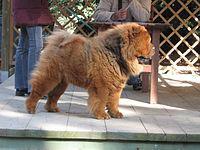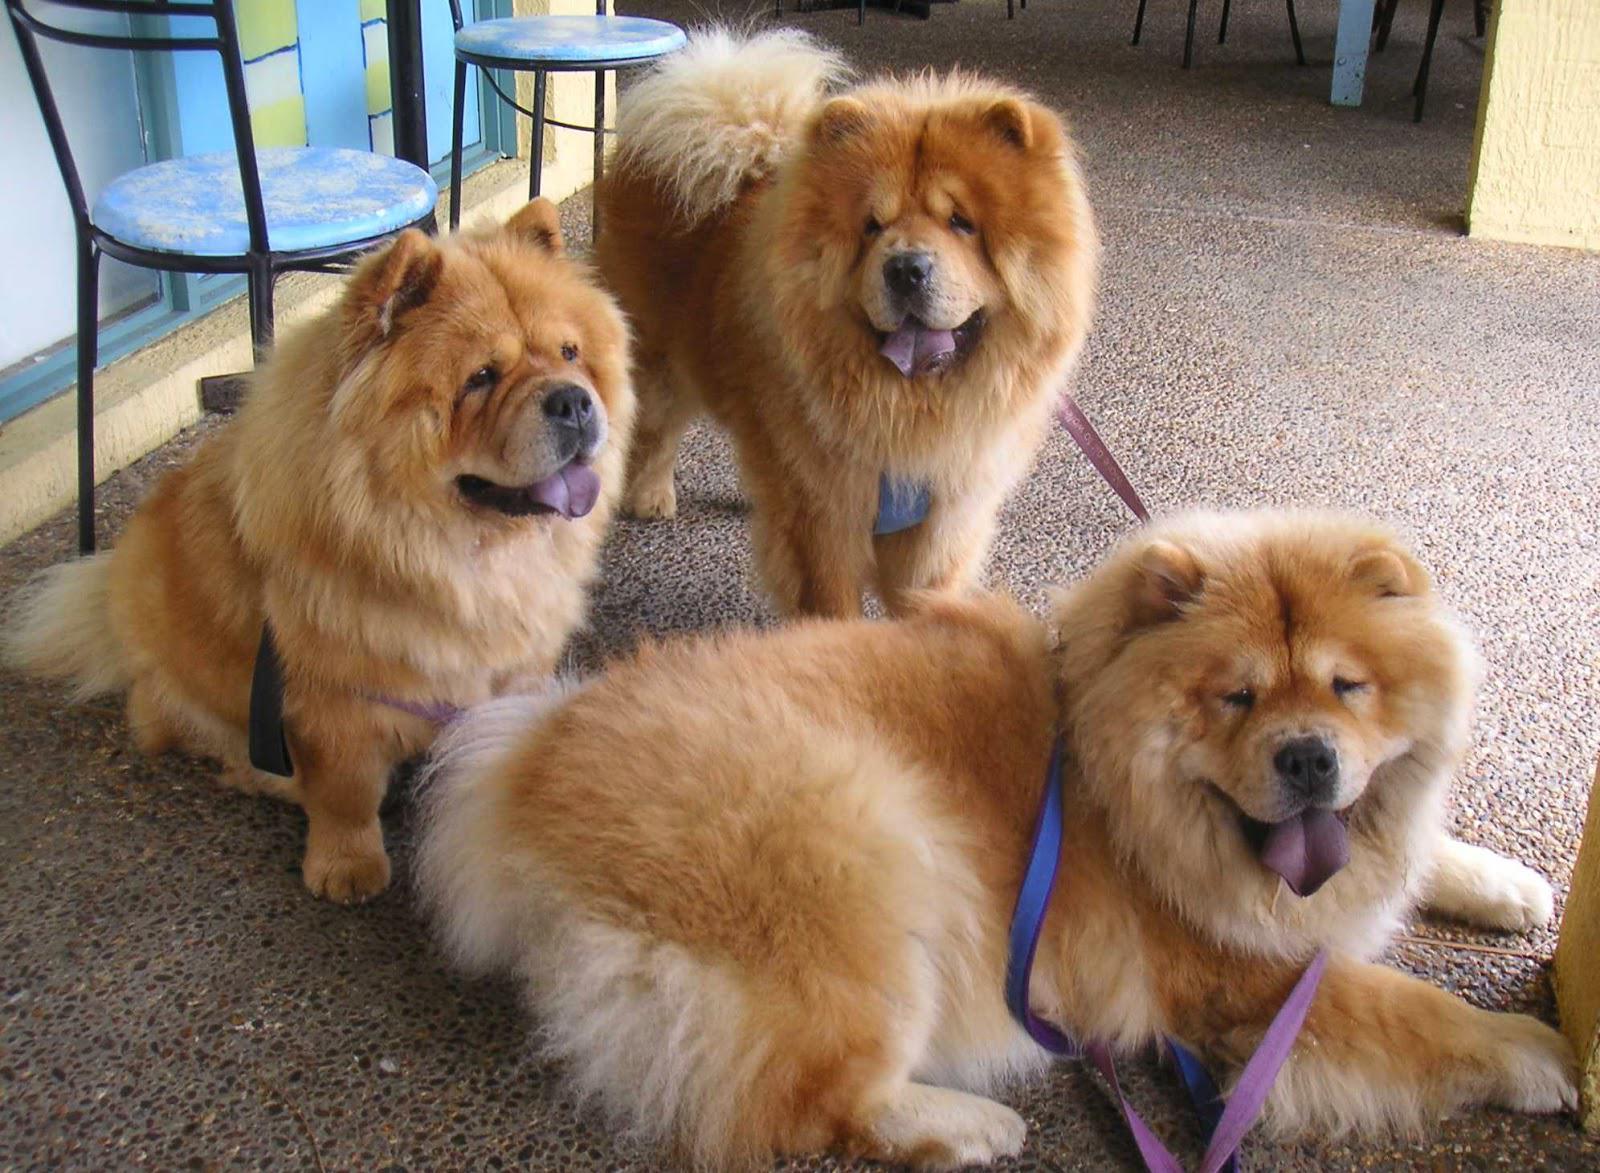The first image is the image on the left, the second image is the image on the right. Analyze the images presented: Is the assertion "There are at least four dogs." valid? Answer yes or no. Yes. 